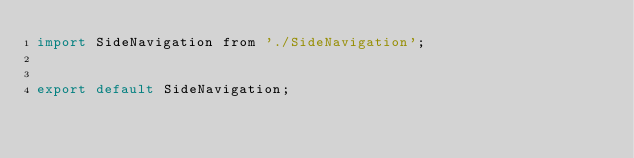<code> <loc_0><loc_0><loc_500><loc_500><_JavaScript_>import SideNavigation from './SideNavigation';


export default SideNavigation;
</code> 